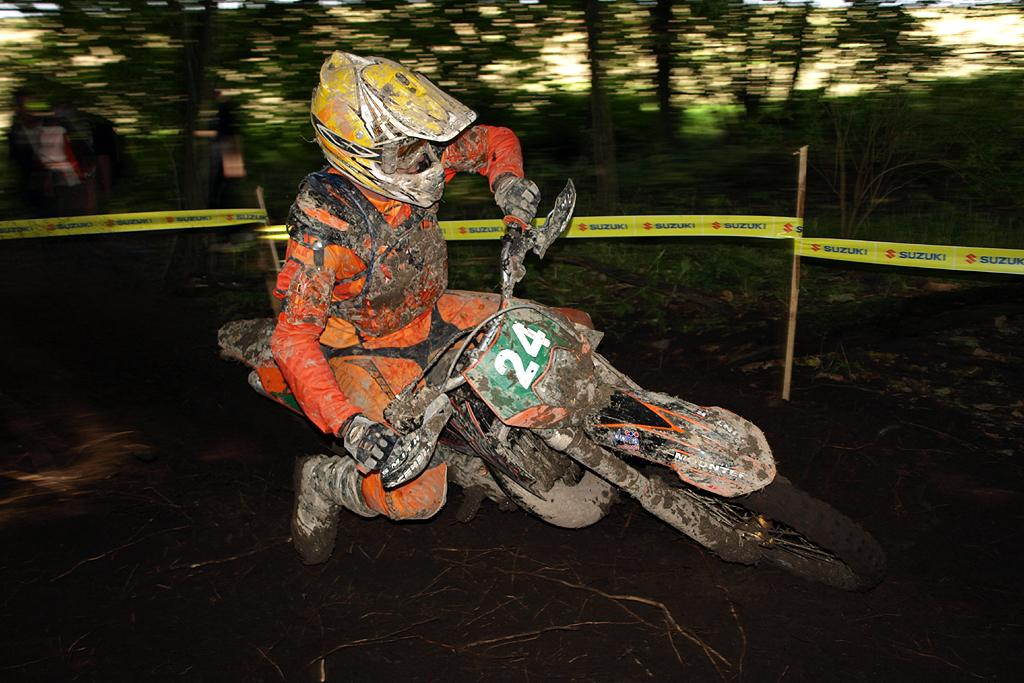What is the person in the image doing? The person is sitting and riding a bike. What safety precaution is the person taking while riding the bike? The person is wearing a helmet. What can be seen in the background of the image? There are trees and barricades with sticks in the background of the image. How would you describe the background of the image? The background is blurry. What type of skirt is the minister wearing in the image? There is no minister or skirt present in the image. 